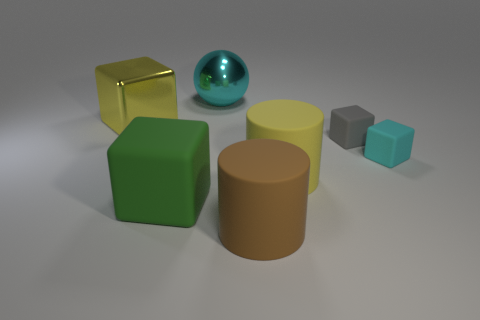Add 3 tiny cyan rubber objects. How many objects exist? 10 Subtract all metallic blocks. How many blocks are left? 3 Subtract 1 balls. How many balls are left? 0 Subtract all cylinders. How many objects are left? 5 Subtract all brown cylinders. How many cylinders are left? 1 Subtract all brown cylinders. Subtract all yellow balls. How many cylinders are left? 1 Subtract all brown balls. How many brown cylinders are left? 1 Subtract all cylinders. Subtract all cyan metal things. How many objects are left? 4 Add 4 tiny gray things. How many tiny gray things are left? 5 Add 7 cyan metal balls. How many cyan metal balls exist? 8 